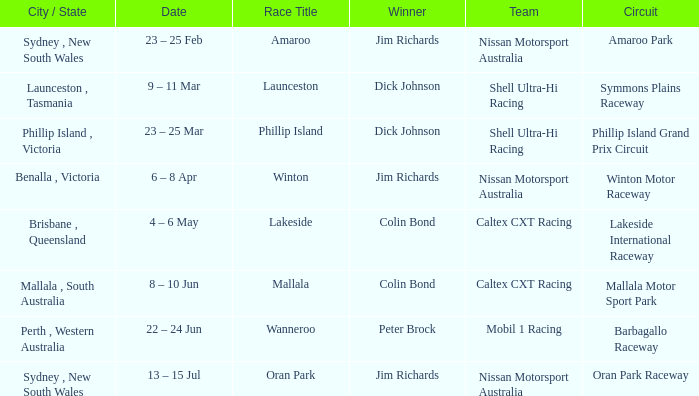Name the team for launceston Shell Ultra-Hi Racing. 